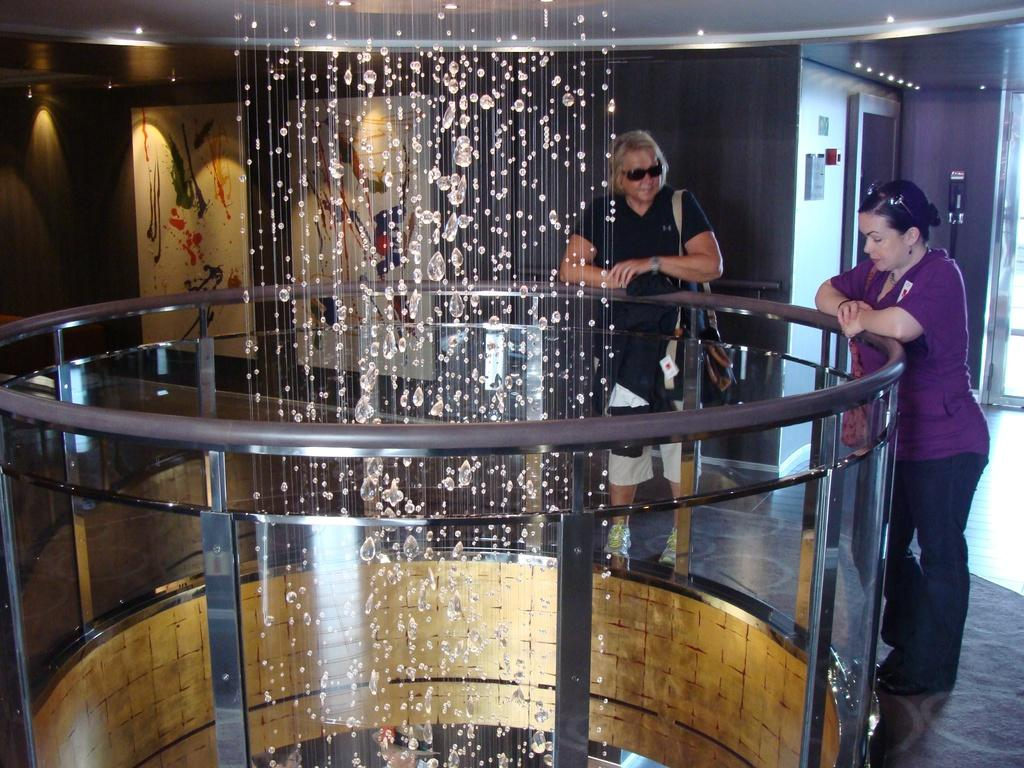What is located in the middle of the image? There is water in the middle of the image. What objects are in the water? There are metal rods in the water. Who or what is inside the metal rods? Two persons are inside the metal rods. What can be seen in the background of the image? There are lights and a painting on a wall in the background of the image. What type of jam is being spread on the lawyer's face in the image? There is no jam or lawyer present in the image; it features water, metal rods, and two persons inside them. How much sand can be seen on the beach in the image? There is no beach or sand present in the image. 